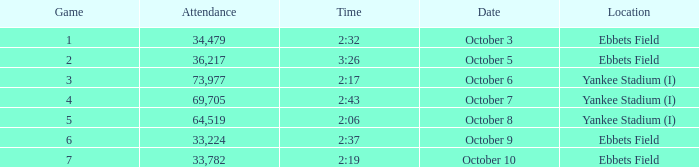What is the location of the game that has a number smaller than 2? Ebbets Field. 